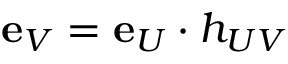Convert formula to latex. <formula><loc_0><loc_0><loc_500><loc_500>{ e } _ { V } = { e } _ { U } \cdot h _ { U V }</formula> 